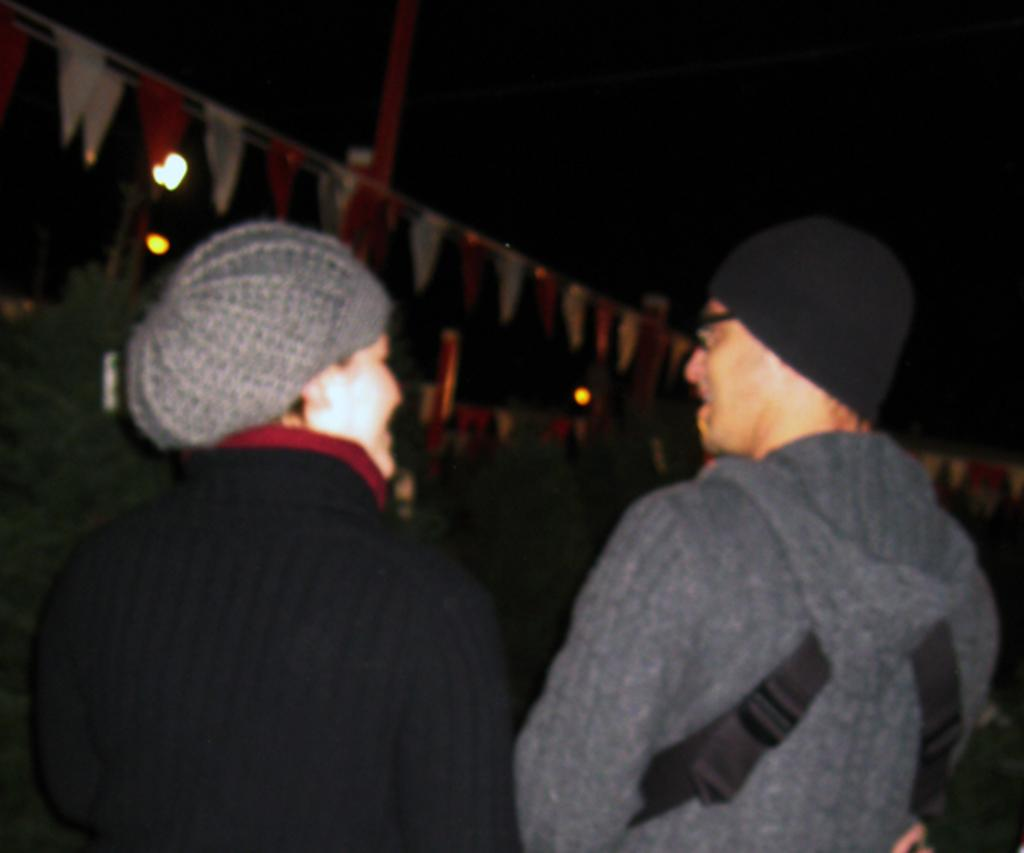How many people are in the image? There are two persons in the image. What can be seen hanging from ropes in the image? There are decorative papers attached to ropes in the image. What is the tall, vertical object in the image? There is a pole in the image. What type of illumination is present in the image? There are lights in the image. How would you describe the lighting conditions in the image? The background of the image is dark. How many dogs are present in the image? There are no dogs visible in the image. What type of quiver is being used by the persons in the image? There is no quiver present in the image; it is not a hunting or archery scene. 